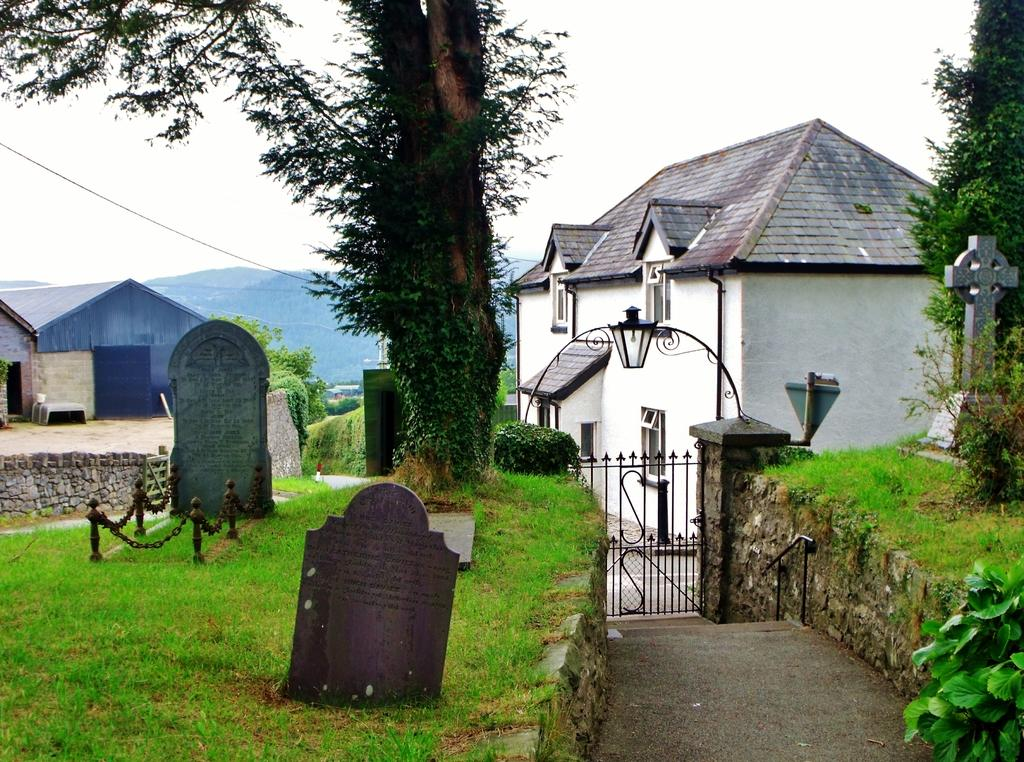What type of objects are on the grass in the image? There are memorial stones on the grass in the image. What type of barrier can be seen in the image? There is a chain fence in the image. Is there an entrance in the image? Yes, there is a gate in the image. What type of structure is present in the image? There is a stone wall in the image. What type of vegetation is visible in the image? There are trees in the image. What type of buildings can be seen in the image? There are houses in the image. What can be seen in the distance in the image? There are hills in the background of the image. What is visible in the sky in the image? The sky is visible in the background of the image. What type of print can be seen on the trees in the image? There is no print visible on the trees in the image. What type of territory is being claimed by the houses in the image? The image does not suggest that the houses are claiming any territory. How many eggs are visible on the memorial stones in the image? There are no eggs present on the memorial stones in the image. 